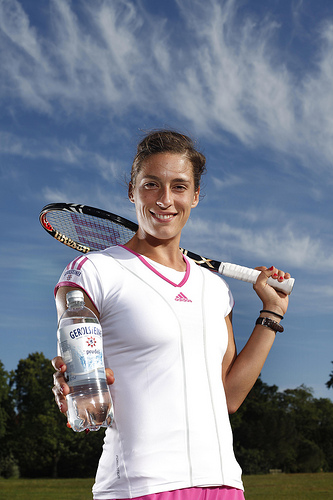How many people are in the photo? 1 